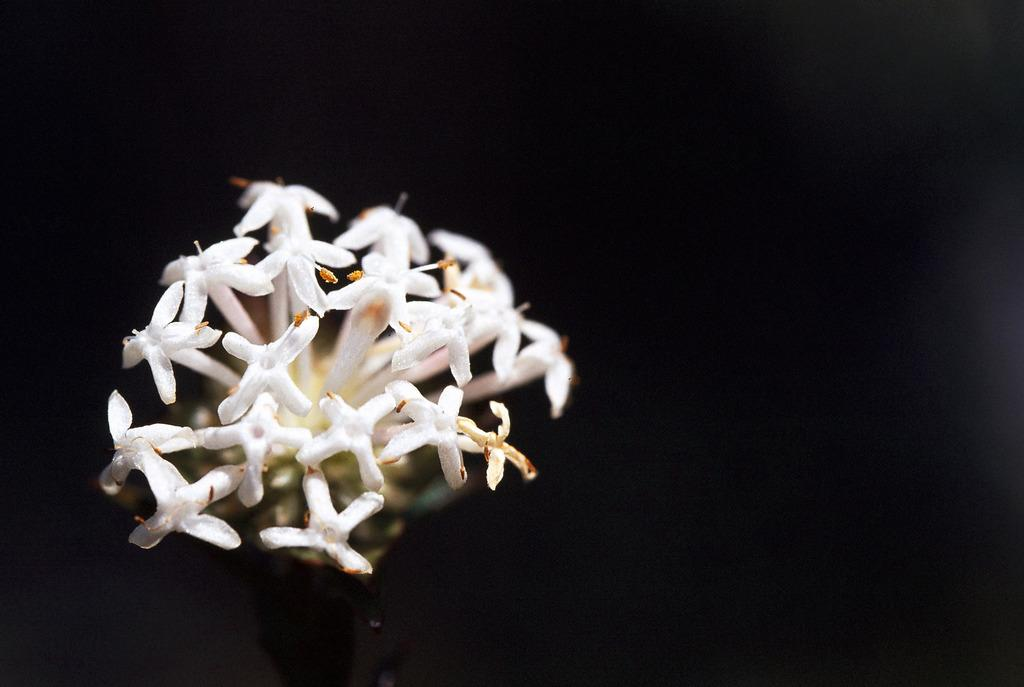What type of flowers are present in the image? There are white color flowers in the image. What color is the background of the image? The background of the image is black. Can you see a sack being carried on a trail in the image? There is no sack or trail present in the image; it only features white flowers against a black background. 